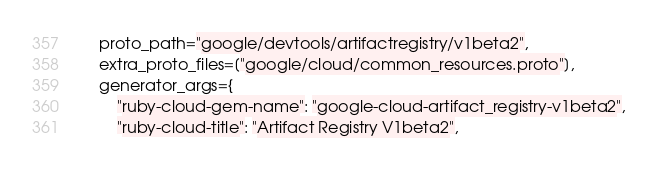Convert code to text. <code><loc_0><loc_0><loc_500><loc_500><_Python_>    proto_path="google/devtools/artifactregistry/v1beta2",
    extra_proto_files=["google/cloud/common_resources.proto"],
    generator_args={
        "ruby-cloud-gem-name": "google-cloud-artifact_registry-v1beta2",
        "ruby-cloud-title": "Artifact Registry V1beta2",</code> 